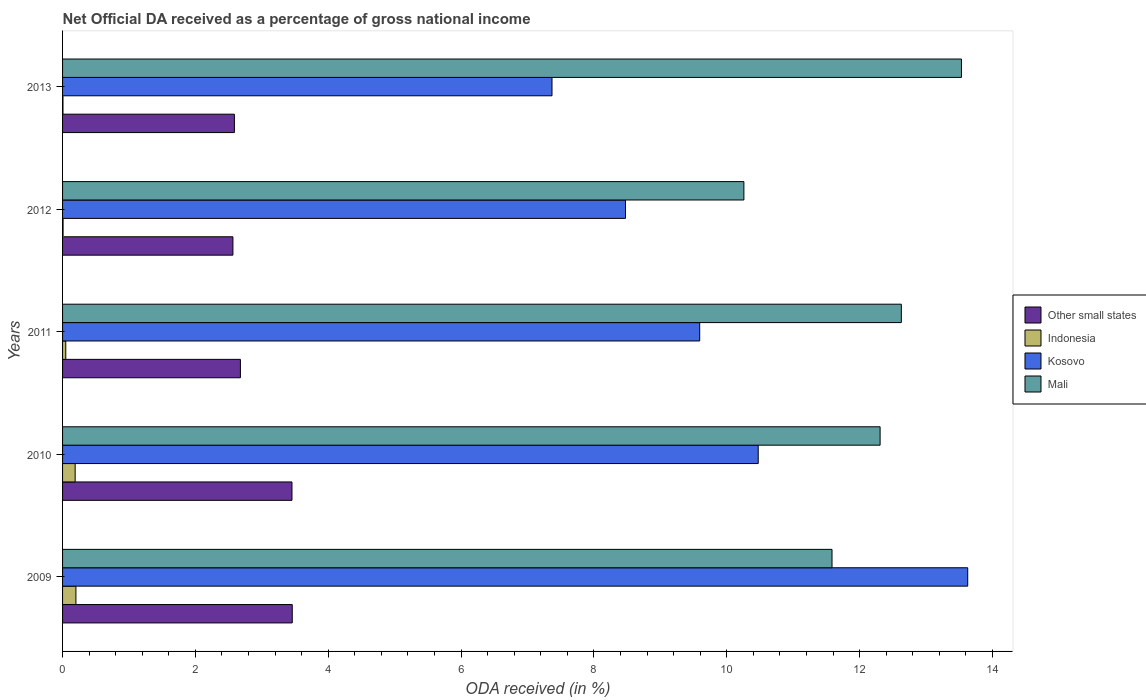Are the number of bars per tick equal to the number of legend labels?
Provide a short and direct response. Yes. How many bars are there on the 2nd tick from the bottom?
Your answer should be very brief. 4. In how many cases, is the number of bars for a given year not equal to the number of legend labels?
Ensure brevity in your answer.  0. What is the net official DA received in Other small states in 2012?
Keep it short and to the point. 2.56. Across all years, what is the maximum net official DA received in Indonesia?
Keep it short and to the point. 0.2. Across all years, what is the minimum net official DA received in Indonesia?
Ensure brevity in your answer.  0.01. In which year was the net official DA received in Indonesia minimum?
Give a very brief answer. 2013. What is the total net official DA received in Kosovo in the graph?
Give a very brief answer. 49.53. What is the difference between the net official DA received in Mali in 2011 and that in 2013?
Offer a terse response. -0.91. What is the difference between the net official DA received in Indonesia in 2010 and the net official DA received in Other small states in 2012?
Keep it short and to the point. -2.38. What is the average net official DA received in Mali per year?
Offer a very short reply. 12.06. In the year 2009, what is the difference between the net official DA received in Mali and net official DA received in Other small states?
Your answer should be compact. 8.13. In how many years, is the net official DA received in Other small states greater than 1.2000000000000002 %?
Your response must be concise. 5. What is the ratio of the net official DA received in Other small states in 2009 to that in 2010?
Your answer should be very brief. 1. Is the net official DA received in Kosovo in 2010 less than that in 2012?
Your response must be concise. No. What is the difference between the highest and the second highest net official DA received in Other small states?
Ensure brevity in your answer.  0. What is the difference between the highest and the lowest net official DA received in Indonesia?
Provide a short and direct response. 0.19. Is the sum of the net official DA received in Indonesia in 2010 and 2011 greater than the maximum net official DA received in Mali across all years?
Your answer should be very brief. No. What does the 2nd bar from the top in 2013 represents?
Offer a terse response. Kosovo. Is it the case that in every year, the sum of the net official DA received in Other small states and net official DA received in Kosovo is greater than the net official DA received in Indonesia?
Make the answer very short. Yes. How many bars are there?
Your answer should be very brief. 20. Are all the bars in the graph horizontal?
Provide a succinct answer. Yes. How many years are there in the graph?
Your response must be concise. 5. Are the values on the major ticks of X-axis written in scientific E-notation?
Offer a very short reply. No. Does the graph contain any zero values?
Make the answer very short. No. Does the graph contain grids?
Give a very brief answer. No. What is the title of the graph?
Offer a terse response. Net Official DA received as a percentage of gross national income. What is the label or title of the X-axis?
Ensure brevity in your answer.  ODA received (in %). What is the ODA received (in %) of Other small states in 2009?
Ensure brevity in your answer.  3.46. What is the ODA received (in %) in Indonesia in 2009?
Ensure brevity in your answer.  0.2. What is the ODA received (in %) in Kosovo in 2009?
Provide a short and direct response. 13.63. What is the ODA received (in %) of Mali in 2009?
Provide a succinct answer. 11.58. What is the ODA received (in %) in Other small states in 2010?
Ensure brevity in your answer.  3.45. What is the ODA received (in %) of Indonesia in 2010?
Your answer should be compact. 0.19. What is the ODA received (in %) of Kosovo in 2010?
Offer a very short reply. 10.47. What is the ODA received (in %) of Mali in 2010?
Offer a very short reply. 12.31. What is the ODA received (in %) of Other small states in 2011?
Provide a short and direct response. 2.68. What is the ODA received (in %) of Indonesia in 2011?
Ensure brevity in your answer.  0.05. What is the ODA received (in %) of Kosovo in 2011?
Make the answer very short. 9.59. What is the ODA received (in %) of Mali in 2011?
Offer a terse response. 12.63. What is the ODA received (in %) of Other small states in 2012?
Give a very brief answer. 2.56. What is the ODA received (in %) of Indonesia in 2012?
Your response must be concise. 0.01. What is the ODA received (in %) in Kosovo in 2012?
Offer a very short reply. 8.47. What is the ODA received (in %) in Mali in 2012?
Ensure brevity in your answer.  10.26. What is the ODA received (in %) of Other small states in 2013?
Keep it short and to the point. 2.59. What is the ODA received (in %) of Indonesia in 2013?
Provide a succinct answer. 0.01. What is the ODA received (in %) of Kosovo in 2013?
Your answer should be very brief. 7.37. What is the ODA received (in %) of Mali in 2013?
Ensure brevity in your answer.  13.53. Across all years, what is the maximum ODA received (in %) in Other small states?
Your response must be concise. 3.46. Across all years, what is the maximum ODA received (in %) of Indonesia?
Keep it short and to the point. 0.2. Across all years, what is the maximum ODA received (in %) of Kosovo?
Ensure brevity in your answer.  13.63. Across all years, what is the maximum ODA received (in %) in Mali?
Offer a very short reply. 13.53. Across all years, what is the minimum ODA received (in %) of Other small states?
Your answer should be compact. 2.56. Across all years, what is the minimum ODA received (in %) of Indonesia?
Your response must be concise. 0.01. Across all years, what is the minimum ODA received (in %) in Kosovo?
Ensure brevity in your answer.  7.37. Across all years, what is the minimum ODA received (in %) of Mali?
Your answer should be very brief. 10.26. What is the total ODA received (in %) in Other small states in the graph?
Make the answer very short. 14.74. What is the total ODA received (in %) of Indonesia in the graph?
Ensure brevity in your answer.  0.45. What is the total ODA received (in %) in Kosovo in the graph?
Offer a very short reply. 49.53. What is the total ODA received (in %) in Mali in the graph?
Provide a short and direct response. 60.31. What is the difference between the ODA received (in %) in Other small states in 2009 and that in 2010?
Ensure brevity in your answer.  0. What is the difference between the ODA received (in %) of Indonesia in 2009 and that in 2010?
Provide a succinct answer. 0.01. What is the difference between the ODA received (in %) of Kosovo in 2009 and that in 2010?
Provide a succinct answer. 3.15. What is the difference between the ODA received (in %) in Mali in 2009 and that in 2010?
Give a very brief answer. -0.72. What is the difference between the ODA received (in %) of Other small states in 2009 and that in 2011?
Provide a succinct answer. 0.78. What is the difference between the ODA received (in %) in Indonesia in 2009 and that in 2011?
Your answer should be very brief. 0.15. What is the difference between the ODA received (in %) in Kosovo in 2009 and that in 2011?
Offer a very short reply. 4.03. What is the difference between the ODA received (in %) of Mali in 2009 and that in 2011?
Give a very brief answer. -1.04. What is the difference between the ODA received (in %) of Other small states in 2009 and that in 2012?
Make the answer very short. 0.89. What is the difference between the ODA received (in %) of Indonesia in 2009 and that in 2012?
Provide a succinct answer. 0.19. What is the difference between the ODA received (in %) of Kosovo in 2009 and that in 2012?
Your answer should be compact. 5.15. What is the difference between the ODA received (in %) of Mali in 2009 and that in 2012?
Make the answer very short. 1.33. What is the difference between the ODA received (in %) of Other small states in 2009 and that in 2013?
Keep it short and to the point. 0.87. What is the difference between the ODA received (in %) in Indonesia in 2009 and that in 2013?
Your response must be concise. 0.2. What is the difference between the ODA received (in %) of Kosovo in 2009 and that in 2013?
Keep it short and to the point. 6.26. What is the difference between the ODA received (in %) in Mali in 2009 and that in 2013?
Give a very brief answer. -1.95. What is the difference between the ODA received (in %) in Other small states in 2010 and that in 2011?
Make the answer very short. 0.78. What is the difference between the ODA received (in %) of Indonesia in 2010 and that in 2011?
Your response must be concise. 0.14. What is the difference between the ODA received (in %) of Kosovo in 2010 and that in 2011?
Make the answer very short. 0.88. What is the difference between the ODA received (in %) in Mali in 2010 and that in 2011?
Provide a succinct answer. -0.32. What is the difference between the ODA received (in %) in Indonesia in 2010 and that in 2012?
Your answer should be compact. 0.18. What is the difference between the ODA received (in %) of Kosovo in 2010 and that in 2012?
Your response must be concise. 2. What is the difference between the ODA received (in %) in Mali in 2010 and that in 2012?
Keep it short and to the point. 2.05. What is the difference between the ODA received (in %) of Other small states in 2010 and that in 2013?
Your response must be concise. 0.87. What is the difference between the ODA received (in %) in Indonesia in 2010 and that in 2013?
Ensure brevity in your answer.  0.18. What is the difference between the ODA received (in %) in Kosovo in 2010 and that in 2013?
Ensure brevity in your answer.  3.1. What is the difference between the ODA received (in %) of Mali in 2010 and that in 2013?
Your answer should be very brief. -1.22. What is the difference between the ODA received (in %) of Other small states in 2011 and that in 2012?
Offer a very short reply. 0.11. What is the difference between the ODA received (in %) of Indonesia in 2011 and that in 2012?
Your answer should be very brief. 0.04. What is the difference between the ODA received (in %) of Kosovo in 2011 and that in 2012?
Offer a terse response. 1.12. What is the difference between the ODA received (in %) in Mali in 2011 and that in 2012?
Your answer should be very brief. 2.37. What is the difference between the ODA received (in %) in Other small states in 2011 and that in 2013?
Provide a short and direct response. 0.09. What is the difference between the ODA received (in %) in Indonesia in 2011 and that in 2013?
Give a very brief answer. 0.04. What is the difference between the ODA received (in %) in Kosovo in 2011 and that in 2013?
Ensure brevity in your answer.  2.22. What is the difference between the ODA received (in %) of Mali in 2011 and that in 2013?
Keep it short and to the point. -0.91. What is the difference between the ODA received (in %) in Other small states in 2012 and that in 2013?
Give a very brief answer. -0.02. What is the difference between the ODA received (in %) in Indonesia in 2012 and that in 2013?
Your response must be concise. 0. What is the difference between the ODA received (in %) of Kosovo in 2012 and that in 2013?
Provide a succinct answer. 1.11. What is the difference between the ODA received (in %) in Mali in 2012 and that in 2013?
Ensure brevity in your answer.  -3.28. What is the difference between the ODA received (in %) in Other small states in 2009 and the ODA received (in %) in Indonesia in 2010?
Make the answer very short. 3.27. What is the difference between the ODA received (in %) of Other small states in 2009 and the ODA received (in %) of Kosovo in 2010?
Make the answer very short. -7.01. What is the difference between the ODA received (in %) of Other small states in 2009 and the ODA received (in %) of Mali in 2010?
Keep it short and to the point. -8.85. What is the difference between the ODA received (in %) in Indonesia in 2009 and the ODA received (in %) in Kosovo in 2010?
Provide a short and direct response. -10.27. What is the difference between the ODA received (in %) in Indonesia in 2009 and the ODA received (in %) in Mali in 2010?
Give a very brief answer. -12.11. What is the difference between the ODA received (in %) in Kosovo in 2009 and the ODA received (in %) in Mali in 2010?
Your answer should be compact. 1.32. What is the difference between the ODA received (in %) of Other small states in 2009 and the ODA received (in %) of Indonesia in 2011?
Offer a terse response. 3.41. What is the difference between the ODA received (in %) in Other small states in 2009 and the ODA received (in %) in Kosovo in 2011?
Your answer should be compact. -6.13. What is the difference between the ODA received (in %) of Other small states in 2009 and the ODA received (in %) of Mali in 2011?
Offer a very short reply. -9.17. What is the difference between the ODA received (in %) of Indonesia in 2009 and the ODA received (in %) of Kosovo in 2011?
Your answer should be compact. -9.39. What is the difference between the ODA received (in %) of Indonesia in 2009 and the ODA received (in %) of Mali in 2011?
Provide a succinct answer. -12.43. What is the difference between the ODA received (in %) of Kosovo in 2009 and the ODA received (in %) of Mali in 2011?
Give a very brief answer. 1. What is the difference between the ODA received (in %) of Other small states in 2009 and the ODA received (in %) of Indonesia in 2012?
Keep it short and to the point. 3.45. What is the difference between the ODA received (in %) of Other small states in 2009 and the ODA received (in %) of Kosovo in 2012?
Ensure brevity in your answer.  -5.02. What is the difference between the ODA received (in %) of Other small states in 2009 and the ODA received (in %) of Mali in 2012?
Your answer should be compact. -6.8. What is the difference between the ODA received (in %) in Indonesia in 2009 and the ODA received (in %) in Kosovo in 2012?
Provide a succinct answer. -8.27. What is the difference between the ODA received (in %) of Indonesia in 2009 and the ODA received (in %) of Mali in 2012?
Your answer should be very brief. -10.06. What is the difference between the ODA received (in %) in Kosovo in 2009 and the ODA received (in %) in Mali in 2012?
Make the answer very short. 3.37. What is the difference between the ODA received (in %) of Other small states in 2009 and the ODA received (in %) of Indonesia in 2013?
Give a very brief answer. 3.45. What is the difference between the ODA received (in %) of Other small states in 2009 and the ODA received (in %) of Kosovo in 2013?
Give a very brief answer. -3.91. What is the difference between the ODA received (in %) of Other small states in 2009 and the ODA received (in %) of Mali in 2013?
Offer a very short reply. -10.07. What is the difference between the ODA received (in %) in Indonesia in 2009 and the ODA received (in %) in Kosovo in 2013?
Make the answer very short. -7.17. What is the difference between the ODA received (in %) of Indonesia in 2009 and the ODA received (in %) of Mali in 2013?
Keep it short and to the point. -13.33. What is the difference between the ODA received (in %) in Kosovo in 2009 and the ODA received (in %) in Mali in 2013?
Provide a short and direct response. 0.09. What is the difference between the ODA received (in %) in Other small states in 2010 and the ODA received (in %) in Indonesia in 2011?
Give a very brief answer. 3.41. What is the difference between the ODA received (in %) in Other small states in 2010 and the ODA received (in %) in Kosovo in 2011?
Your answer should be compact. -6.14. What is the difference between the ODA received (in %) in Other small states in 2010 and the ODA received (in %) in Mali in 2011?
Your answer should be very brief. -9.17. What is the difference between the ODA received (in %) of Indonesia in 2010 and the ODA received (in %) of Kosovo in 2011?
Ensure brevity in your answer.  -9.4. What is the difference between the ODA received (in %) in Indonesia in 2010 and the ODA received (in %) in Mali in 2011?
Offer a terse response. -12.44. What is the difference between the ODA received (in %) in Kosovo in 2010 and the ODA received (in %) in Mali in 2011?
Provide a succinct answer. -2.15. What is the difference between the ODA received (in %) of Other small states in 2010 and the ODA received (in %) of Indonesia in 2012?
Make the answer very short. 3.45. What is the difference between the ODA received (in %) in Other small states in 2010 and the ODA received (in %) in Kosovo in 2012?
Keep it short and to the point. -5.02. What is the difference between the ODA received (in %) in Other small states in 2010 and the ODA received (in %) in Mali in 2012?
Ensure brevity in your answer.  -6.8. What is the difference between the ODA received (in %) of Indonesia in 2010 and the ODA received (in %) of Kosovo in 2012?
Make the answer very short. -8.29. What is the difference between the ODA received (in %) of Indonesia in 2010 and the ODA received (in %) of Mali in 2012?
Offer a very short reply. -10.07. What is the difference between the ODA received (in %) of Kosovo in 2010 and the ODA received (in %) of Mali in 2012?
Give a very brief answer. 0.22. What is the difference between the ODA received (in %) of Other small states in 2010 and the ODA received (in %) of Indonesia in 2013?
Make the answer very short. 3.45. What is the difference between the ODA received (in %) in Other small states in 2010 and the ODA received (in %) in Kosovo in 2013?
Ensure brevity in your answer.  -3.91. What is the difference between the ODA received (in %) in Other small states in 2010 and the ODA received (in %) in Mali in 2013?
Make the answer very short. -10.08. What is the difference between the ODA received (in %) in Indonesia in 2010 and the ODA received (in %) in Kosovo in 2013?
Offer a terse response. -7.18. What is the difference between the ODA received (in %) of Indonesia in 2010 and the ODA received (in %) of Mali in 2013?
Your answer should be compact. -13.34. What is the difference between the ODA received (in %) in Kosovo in 2010 and the ODA received (in %) in Mali in 2013?
Ensure brevity in your answer.  -3.06. What is the difference between the ODA received (in %) in Other small states in 2011 and the ODA received (in %) in Indonesia in 2012?
Offer a terse response. 2.67. What is the difference between the ODA received (in %) in Other small states in 2011 and the ODA received (in %) in Kosovo in 2012?
Offer a terse response. -5.8. What is the difference between the ODA received (in %) of Other small states in 2011 and the ODA received (in %) of Mali in 2012?
Your answer should be compact. -7.58. What is the difference between the ODA received (in %) of Indonesia in 2011 and the ODA received (in %) of Kosovo in 2012?
Provide a short and direct response. -8.43. What is the difference between the ODA received (in %) of Indonesia in 2011 and the ODA received (in %) of Mali in 2012?
Make the answer very short. -10.21. What is the difference between the ODA received (in %) of Kosovo in 2011 and the ODA received (in %) of Mali in 2012?
Offer a terse response. -0.67. What is the difference between the ODA received (in %) in Other small states in 2011 and the ODA received (in %) in Indonesia in 2013?
Ensure brevity in your answer.  2.67. What is the difference between the ODA received (in %) of Other small states in 2011 and the ODA received (in %) of Kosovo in 2013?
Your answer should be very brief. -4.69. What is the difference between the ODA received (in %) in Other small states in 2011 and the ODA received (in %) in Mali in 2013?
Offer a terse response. -10.86. What is the difference between the ODA received (in %) of Indonesia in 2011 and the ODA received (in %) of Kosovo in 2013?
Your answer should be compact. -7.32. What is the difference between the ODA received (in %) of Indonesia in 2011 and the ODA received (in %) of Mali in 2013?
Offer a very short reply. -13.48. What is the difference between the ODA received (in %) of Kosovo in 2011 and the ODA received (in %) of Mali in 2013?
Provide a short and direct response. -3.94. What is the difference between the ODA received (in %) in Other small states in 2012 and the ODA received (in %) in Indonesia in 2013?
Make the answer very short. 2.56. What is the difference between the ODA received (in %) of Other small states in 2012 and the ODA received (in %) of Kosovo in 2013?
Give a very brief answer. -4.8. What is the difference between the ODA received (in %) of Other small states in 2012 and the ODA received (in %) of Mali in 2013?
Ensure brevity in your answer.  -10.97. What is the difference between the ODA received (in %) of Indonesia in 2012 and the ODA received (in %) of Kosovo in 2013?
Give a very brief answer. -7.36. What is the difference between the ODA received (in %) in Indonesia in 2012 and the ODA received (in %) in Mali in 2013?
Give a very brief answer. -13.52. What is the difference between the ODA received (in %) in Kosovo in 2012 and the ODA received (in %) in Mali in 2013?
Provide a succinct answer. -5.06. What is the average ODA received (in %) in Other small states per year?
Provide a short and direct response. 2.95. What is the average ODA received (in %) of Indonesia per year?
Your answer should be very brief. 0.09. What is the average ODA received (in %) in Kosovo per year?
Offer a terse response. 9.91. What is the average ODA received (in %) of Mali per year?
Your answer should be compact. 12.06. In the year 2009, what is the difference between the ODA received (in %) of Other small states and ODA received (in %) of Indonesia?
Ensure brevity in your answer.  3.26. In the year 2009, what is the difference between the ODA received (in %) in Other small states and ODA received (in %) in Kosovo?
Provide a short and direct response. -10.17. In the year 2009, what is the difference between the ODA received (in %) of Other small states and ODA received (in %) of Mali?
Provide a short and direct response. -8.13. In the year 2009, what is the difference between the ODA received (in %) of Indonesia and ODA received (in %) of Kosovo?
Keep it short and to the point. -13.43. In the year 2009, what is the difference between the ODA received (in %) in Indonesia and ODA received (in %) in Mali?
Keep it short and to the point. -11.38. In the year 2009, what is the difference between the ODA received (in %) of Kosovo and ODA received (in %) of Mali?
Your response must be concise. 2.04. In the year 2010, what is the difference between the ODA received (in %) of Other small states and ODA received (in %) of Indonesia?
Offer a very short reply. 3.26. In the year 2010, what is the difference between the ODA received (in %) of Other small states and ODA received (in %) of Kosovo?
Keep it short and to the point. -7.02. In the year 2010, what is the difference between the ODA received (in %) of Other small states and ODA received (in %) of Mali?
Make the answer very short. -8.85. In the year 2010, what is the difference between the ODA received (in %) of Indonesia and ODA received (in %) of Kosovo?
Provide a succinct answer. -10.28. In the year 2010, what is the difference between the ODA received (in %) in Indonesia and ODA received (in %) in Mali?
Offer a very short reply. -12.12. In the year 2010, what is the difference between the ODA received (in %) of Kosovo and ODA received (in %) of Mali?
Give a very brief answer. -1.83. In the year 2011, what is the difference between the ODA received (in %) in Other small states and ODA received (in %) in Indonesia?
Make the answer very short. 2.63. In the year 2011, what is the difference between the ODA received (in %) of Other small states and ODA received (in %) of Kosovo?
Provide a short and direct response. -6.91. In the year 2011, what is the difference between the ODA received (in %) in Other small states and ODA received (in %) in Mali?
Offer a very short reply. -9.95. In the year 2011, what is the difference between the ODA received (in %) of Indonesia and ODA received (in %) of Kosovo?
Provide a succinct answer. -9.54. In the year 2011, what is the difference between the ODA received (in %) in Indonesia and ODA received (in %) in Mali?
Provide a short and direct response. -12.58. In the year 2011, what is the difference between the ODA received (in %) in Kosovo and ODA received (in %) in Mali?
Your answer should be compact. -3.04. In the year 2012, what is the difference between the ODA received (in %) of Other small states and ODA received (in %) of Indonesia?
Make the answer very short. 2.56. In the year 2012, what is the difference between the ODA received (in %) of Other small states and ODA received (in %) of Kosovo?
Your answer should be compact. -5.91. In the year 2012, what is the difference between the ODA received (in %) in Other small states and ODA received (in %) in Mali?
Offer a terse response. -7.69. In the year 2012, what is the difference between the ODA received (in %) in Indonesia and ODA received (in %) in Kosovo?
Ensure brevity in your answer.  -8.47. In the year 2012, what is the difference between the ODA received (in %) in Indonesia and ODA received (in %) in Mali?
Provide a short and direct response. -10.25. In the year 2012, what is the difference between the ODA received (in %) in Kosovo and ODA received (in %) in Mali?
Your answer should be compact. -1.78. In the year 2013, what is the difference between the ODA received (in %) of Other small states and ODA received (in %) of Indonesia?
Give a very brief answer. 2.58. In the year 2013, what is the difference between the ODA received (in %) in Other small states and ODA received (in %) in Kosovo?
Provide a succinct answer. -4.78. In the year 2013, what is the difference between the ODA received (in %) in Other small states and ODA received (in %) in Mali?
Ensure brevity in your answer.  -10.95. In the year 2013, what is the difference between the ODA received (in %) in Indonesia and ODA received (in %) in Kosovo?
Provide a succinct answer. -7.36. In the year 2013, what is the difference between the ODA received (in %) in Indonesia and ODA received (in %) in Mali?
Give a very brief answer. -13.53. In the year 2013, what is the difference between the ODA received (in %) in Kosovo and ODA received (in %) in Mali?
Your response must be concise. -6.16. What is the ratio of the ODA received (in %) of Other small states in 2009 to that in 2010?
Offer a very short reply. 1. What is the ratio of the ODA received (in %) in Indonesia in 2009 to that in 2010?
Your response must be concise. 1.06. What is the ratio of the ODA received (in %) of Kosovo in 2009 to that in 2010?
Provide a succinct answer. 1.3. What is the ratio of the ODA received (in %) of Other small states in 2009 to that in 2011?
Provide a succinct answer. 1.29. What is the ratio of the ODA received (in %) in Indonesia in 2009 to that in 2011?
Offer a very short reply. 4.15. What is the ratio of the ODA received (in %) in Kosovo in 2009 to that in 2011?
Keep it short and to the point. 1.42. What is the ratio of the ODA received (in %) in Mali in 2009 to that in 2011?
Your answer should be very brief. 0.92. What is the ratio of the ODA received (in %) of Other small states in 2009 to that in 2012?
Your response must be concise. 1.35. What is the ratio of the ODA received (in %) in Indonesia in 2009 to that in 2012?
Your response must be concise. 26.42. What is the ratio of the ODA received (in %) in Kosovo in 2009 to that in 2012?
Keep it short and to the point. 1.61. What is the ratio of the ODA received (in %) of Mali in 2009 to that in 2012?
Give a very brief answer. 1.13. What is the ratio of the ODA received (in %) of Other small states in 2009 to that in 2013?
Your answer should be compact. 1.34. What is the ratio of the ODA received (in %) in Indonesia in 2009 to that in 2013?
Provide a succinct answer. 33.29. What is the ratio of the ODA received (in %) of Kosovo in 2009 to that in 2013?
Make the answer very short. 1.85. What is the ratio of the ODA received (in %) of Mali in 2009 to that in 2013?
Give a very brief answer. 0.86. What is the ratio of the ODA received (in %) of Other small states in 2010 to that in 2011?
Offer a terse response. 1.29. What is the ratio of the ODA received (in %) of Indonesia in 2010 to that in 2011?
Offer a terse response. 3.92. What is the ratio of the ODA received (in %) of Kosovo in 2010 to that in 2011?
Give a very brief answer. 1.09. What is the ratio of the ODA received (in %) of Mali in 2010 to that in 2011?
Offer a very short reply. 0.97. What is the ratio of the ODA received (in %) in Other small states in 2010 to that in 2012?
Ensure brevity in your answer.  1.35. What is the ratio of the ODA received (in %) in Indonesia in 2010 to that in 2012?
Keep it short and to the point. 24.92. What is the ratio of the ODA received (in %) of Kosovo in 2010 to that in 2012?
Offer a terse response. 1.24. What is the ratio of the ODA received (in %) in Mali in 2010 to that in 2012?
Offer a terse response. 1.2. What is the ratio of the ODA received (in %) of Other small states in 2010 to that in 2013?
Your answer should be compact. 1.34. What is the ratio of the ODA received (in %) in Indonesia in 2010 to that in 2013?
Keep it short and to the point. 31.41. What is the ratio of the ODA received (in %) of Kosovo in 2010 to that in 2013?
Provide a succinct answer. 1.42. What is the ratio of the ODA received (in %) of Mali in 2010 to that in 2013?
Make the answer very short. 0.91. What is the ratio of the ODA received (in %) of Other small states in 2011 to that in 2012?
Your response must be concise. 1.04. What is the ratio of the ODA received (in %) in Indonesia in 2011 to that in 2012?
Your response must be concise. 6.36. What is the ratio of the ODA received (in %) in Kosovo in 2011 to that in 2012?
Offer a very short reply. 1.13. What is the ratio of the ODA received (in %) of Mali in 2011 to that in 2012?
Offer a terse response. 1.23. What is the ratio of the ODA received (in %) of Other small states in 2011 to that in 2013?
Keep it short and to the point. 1.03. What is the ratio of the ODA received (in %) of Indonesia in 2011 to that in 2013?
Offer a terse response. 8.02. What is the ratio of the ODA received (in %) in Kosovo in 2011 to that in 2013?
Your response must be concise. 1.3. What is the ratio of the ODA received (in %) of Mali in 2011 to that in 2013?
Provide a succinct answer. 0.93. What is the ratio of the ODA received (in %) of Indonesia in 2012 to that in 2013?
Ensure brevity in your answer.  1.26. What is the ratio of the ODA received (in %) of Kosovo in 2012 to that in 2013?
Your response must be concise. 1.15. What is the ratio of the ODA received (in %) in Mali in 2012 to that in 2013?
Keep it short and to the point. 0.76. What is the difference between the highest and the second highest ODA received (in %) in Other small states?
Provide a short and direct response. 0. What is the difference between the highest and the second highest ODA received (in %) in Indonesia?
Your answer should be very brief. 0.01. What is the difference between the highest and the second highest ODA received (in %) of Kosovo?
Keep it short and to the point. 3.15. What is the difference between the highest and the second highest ODA received (in %) in Mali?
Make the answer very short. 0.91. What is the difference between the highest and the lowest ODA received (in %) of Other small states?
Offer a terse response. 0.89. What is the difference between the highest and the lowest ODA received (in %) in Indonesia?
Your answer should be compact. 0.2. What is the difference between the highest and the lowest ODA received (in %) in Kosovo?
Make the answer very short. 6.26. What is the difference between the highest and the lowest ODA received (in %) in Mali?
Provide a succinct answer. 3.28. 